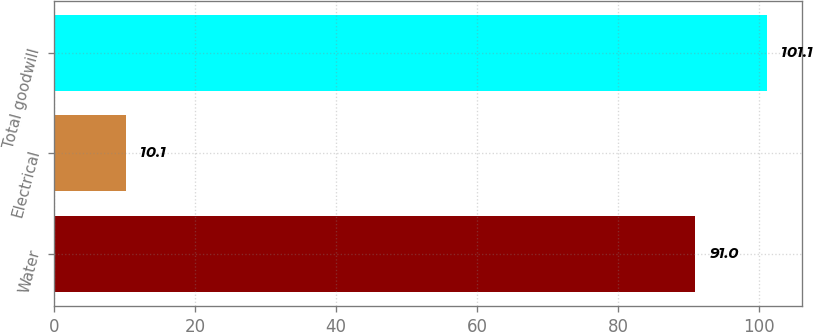Convert chart. <chart><loc_0><loc_0><loc_500><loc_500><bar_chart><fcel>Water<fcel>Electrical<fcel>Total goodwill<nl><fcel>91<fcel>10.1<fcel>101.1<nl></chart> 